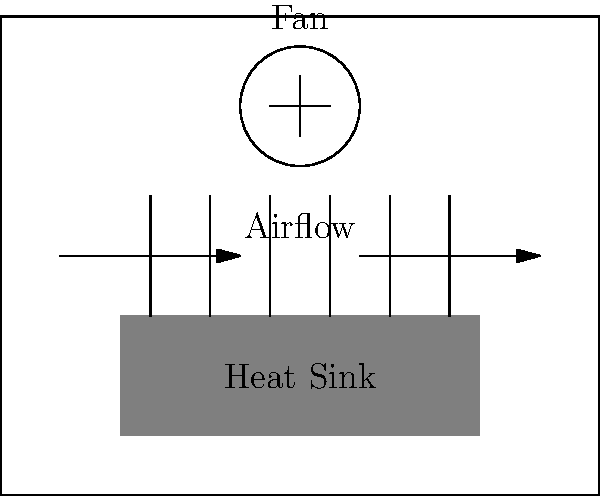In a gaming console's cooling system, the heat sink fins are designed to maximize heat dissipation. If the total surface area of the heat sink fins is increased by 25%, approximately what percentage increase in heat dissipation rate can be expected, assuming all other factors remain constant? To solve this problem, let's follow these steps:

1. Recall that heat dissipation rate is directly proportional to the surface area of the heat sink, assuming other factors remain constant. This relationship can be expressed as:

   $Q \propto A$

   Where $Q$ is the heat dissipation rate and $A$ is the surface area.

2. Let's denote the initial surface area as $A_0$ and the initial heat dissipation rate as $Q_0$.

3. The new surface area after a 25% increase is:

   $A_1 = A_0 + 0.25A_0 = 1.25A_0$

4. Due to the proportional relationship, we can write:

   $\frac{Q_1}{Q_0} = \frac{A_1}{A_0}$

5. Substituting the value for $A_1$:

   $\frac{Q_1}{Q_0} = \frac{1.25A_0}{A_0} = 1.25$

6. To express this as a percentage increase:

   Percentage increase = $(1.25 - 1) \times 100\% = 0.25 \times 100\% = 25\%$

Therefore, a 25% increase in surface area would result in approximately a 25% increase in heat dissipation rate, assuming all other factors remain constant.
Answer: 25% 